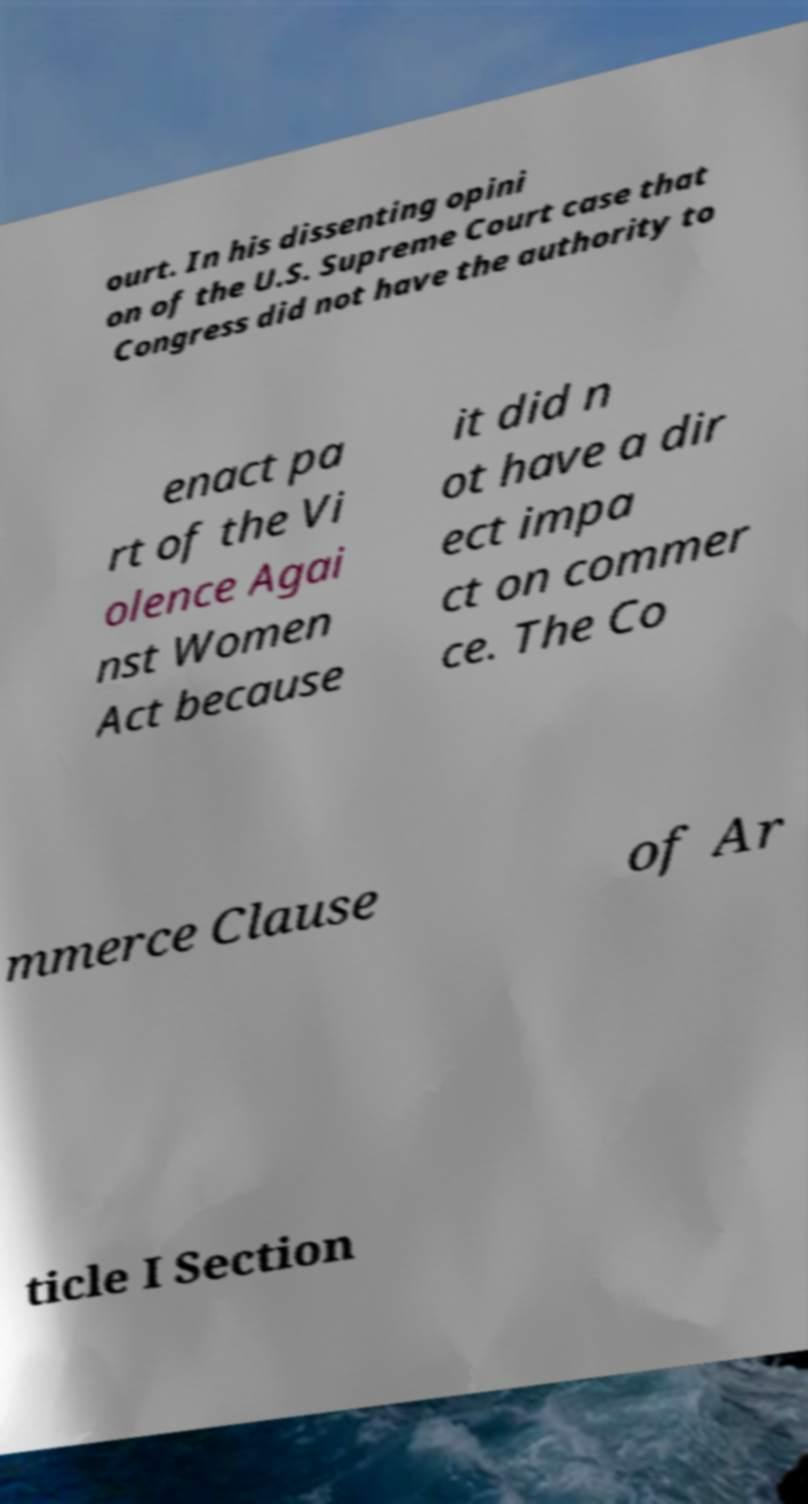Can you accurately transcribe the text from the provided image for me? ourt. In his dissenting opini on of the U.S. Supreme Court case that Congress did not have the authority to enact pa rt of the Vi olence Agai nst Women Act because it did n ot have a dir ect impa ct on commer ce. The Co mmerce Clause of Ar ticle I Section 